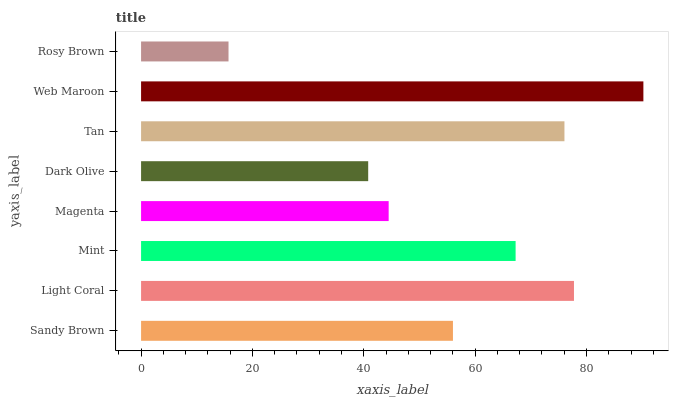Is Rosy Brown the minimum?
Answer yes or no. Yes. Is Web Maroon the maximum?
Answer yes or no. Yes. Is Light Coral the minimum?
Answer yes or no. No. Is Light Coral the maximum?
Answer yes or no. No. Is Light Coral greater than Sandy Brown?
Answer yes or no. Yes. Is Sandy Brown less than Light Coral?
Answer yes or no. Yes. Is Sandy Brown greater than Light Coral?
Answer yes or no. No. Is Light Coral less than Sandy Brown?
Answer yes or no. No. Is Mint the high median?
Answer yes or no. Yes. Is Sandy Brown the low median?
Answer yes or no. Yes. Is Dark Olive the high median?
Answer yes or no. No. Is Web Maroon the low median?
Answer yes or no. No. 